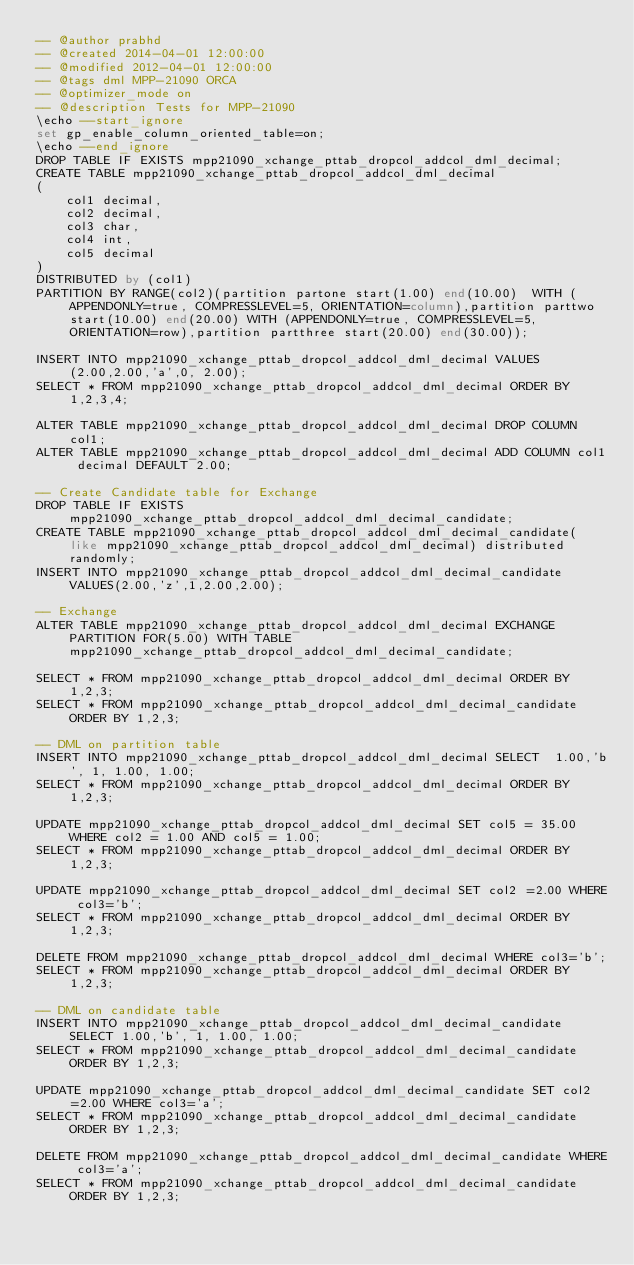Convert code to text. <code><loc_0><loc_0><loc_500><loc_500><_SQL_>-- @author prabhd 
-- @created 2014-04-01 12:00:00
-- @modified 2012-04-01 12:00:00
-- @tags dml MPP-21090 ORCA
-- @optimizer_mode on	
-- @description Tests for MPP-21090
\echo --start_ignore
set gp_enable_column_oriented_table=on;
\echo --end_ignore
DROP TABLE IF EXISTS mpp21090_xchange_pttab_dropcol_addcol_dml_decimal;
CREATE TABLE mpp21090_xchange_pttab_dropcol_addcol_dml_decimal
(
    col1 decimal,
    col2 decimal,
    col3 char,
    col4 int,
    col5 decimal
) 
DISTRIBUTED by (col1)
PARTITION BY RANGE(col2)(partition partone start(1.00) end(10.00)  WITH (APPENDONLY=true, COMPRESSLEVEL=5, ORIENTATION=column),partition parttwo start(10.00) end(20.00) WITH (APPENDONLY=true, COMPRESSLEVEL=5, ORIENTATION=row),partition partthree start(20.00) end(30.00));

INSERT INTO mpp21090_xchange_pttab_dropcol_addcol_dml_decimal VALUES(2.00,2.00,'a',0, 2.00);
SELECT * FROM mpp21090_xchange_pttab_dropcol_addcol_dml_decimal ORDER BY 1,2,3,4;

ALTER TABLE mpp21090_xchange_pttab_dropcol_addcol_dml_decimal DROP COLUMN col1;
ALTER TABLE mpp21090_xchange_pttab_dropcol_addcol_dml_decimal ADD COLUMN col1 decimal DEFAULT 2.00;

-- Create Candidate table for Exchange
DROP TABLE IF EXISTS mpp21090_xchange_pttab_dropcol_addcol_dml_decimal_candidate;
CREATE TABLE mpp21090_xchange_pttab_dropcol_addcol_dml_decimal_candidate( like mpp21090_xchange_pttab_dropcol_addcol_dml_decimal) distributed randomly;
INSERT INTO mpp21090_xchange_pttab_dropcol_addcol_dml_decimal_candidate VALUES(2.00,'z',1,2.00,2.00);

-- Exchange 
ALTER TABLE mpp21090_xchange_pttab_dropcol_addcol_dml_decimal EXCHANGE PARTITION FOR(5.00) WITH TABLE mpp21090_xchange_pttab_dropcol_addcol_dml_decimal_candidate;

SELECT * FROM mpp21090_xchange_pttab_dropcol_addcol_dml_decimal ORDER BY 1,2,3;
SELECT * FROM mpp21090_xchange_pttab_dropcol_addcol_dml_decimal_candidate ORDER BY 1,2,3;

-- DML on partition table
INSERT INTO mpp21090_xchange_pttab_dropcol_addcol_dml_decimal SELECT  1.00,'b', 1, 1.00, 1.00;
SELECT * FROM mpp21090_xchange_pttab_dropcol_addcol_dml_decimal ORDER BY 1,2,3;

UPDATE mpp21090_xchange_pttab_dropcol_addcol_dml_decimal SET col5 = 35.00 WHERE col2 = 1.00 AND col5 = 1.00;
SELECT * FROM mpp21090_xchange_pttab_dropcol_addcol_dml_decimal ORDER BY 1,2,3;

UPDATE mpp21090_xchange_pttab_dropcol_addcol_dml_decimal SET col2 =2.00 WHERE col3='b';
SELECT * FROM mpp21090_xchange_pttab_dropcol_addcol_dml_decimal ORDER BY 1,2,3;

DELETE FROM mpp21090_xchange_pttab_dropcol_addcol_dml_decimal WHERE col3='b';
SELECT * FROM mpp21090_xchange_pttab_dropcol_addcol_dml_decimal ORDER BY 1,2,3;

-- DML on candidate table
INSERT INTO mpp21090_xchange_pttab_dropcol_addcol_dml_decimal_candidate SELECT 1.00,'b', 1, 1.00, 1.00;
SELECT * FROM mpp21090_xchange_pttab_dropcol_addcol_dml_decimal_candidate ORDER BY 1,2,3;

UPDATE mpp21090_xchange_pttab_dropcol_addcol_dml_decimal_candidate SET col2=2.00 WHERE col3='a';
SELECT * FROM mpp21090_xchange_pttab_dropcol_addcol_dml_decimal_candidate ORDER BY 1,2,3;

DELETE FROM mpp21090_xchange_pttab_dropcol_addcol_dml_decimal_candidate WHERE col3='a';
SELECT * FROM mpp21090_xchange_pttab_dropcol_addcol_dml_decimal_candidate ORDER BY 1,2,3;
</code> 